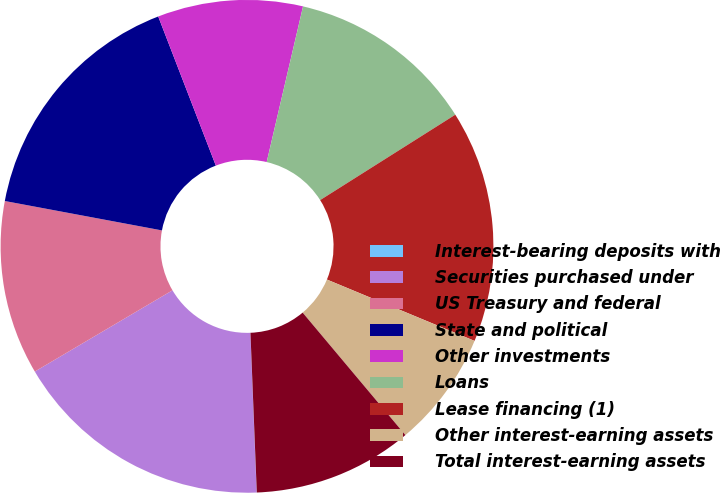Convert chart. <chart><loc_0><loc_0><loc_500><loc_500><pie_chart><fcel>Interest-bearing deposits with<fcel>Securities purchased under<fcel>US Treasury and federal<fcel>State and political<fcel>Other investments<fcel>Loans<fcel>Lease financing (1)<fcel>Other interest-earning assets<fcel>Total interest-earning assets<nl><fcel>0.01%<fcel>17.14%<fcel>11.43%<fcel>16.19%<fcel>9.52%<fcel>12.38%<fcel>15.24%<fcel>7.62%<fcel>10.48%<nl></chart> 